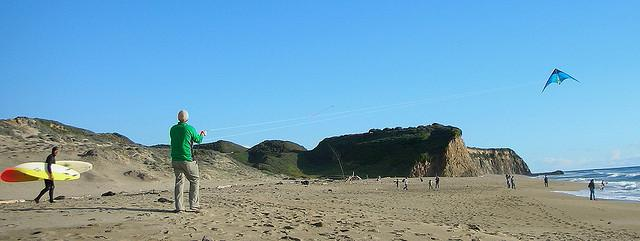What is the man carrying to the water? surfboards 